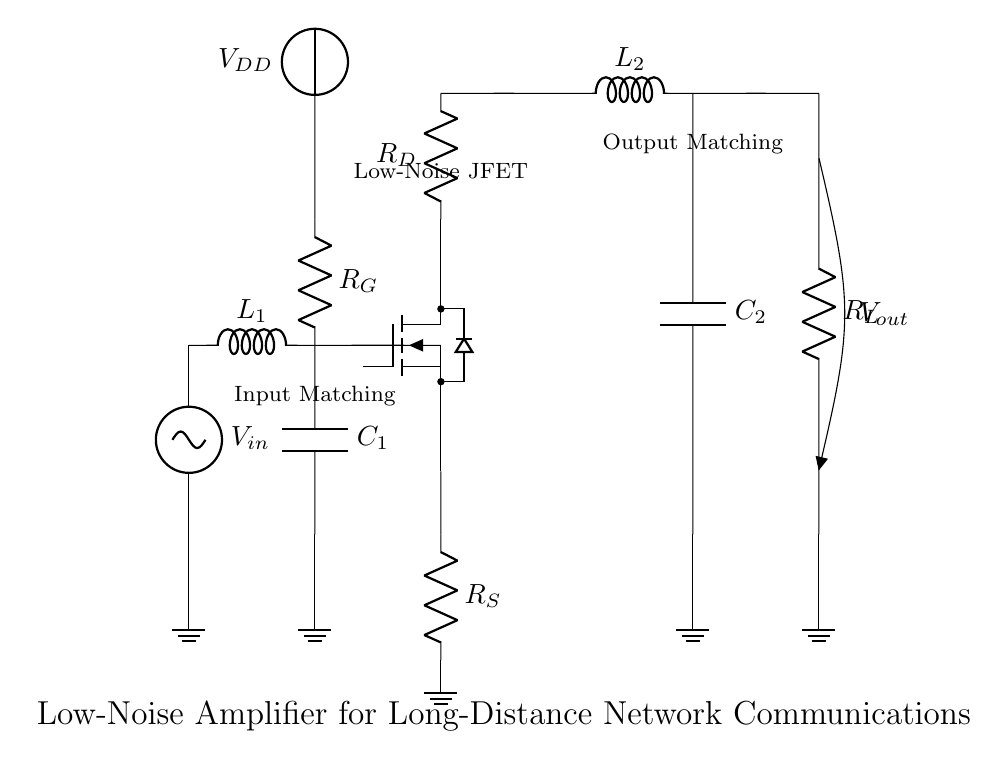What type of amplifier is used in this circuit? The circuit diagram shows a low-noise amplifier, as indicated by the label near the JFET. This type of amplifier is specifically designed to minimize added noise while amplifying weak signals.
Answer: low-noise amplifier What component is represented by "C1"? "C1" is a capacitor, which is used in the input matching network to help filter and match the impedance of the incoming signal. Capacitors in this context improve signal integrity and stability.
Answer: capacitor What is the purpose of the inductor "L1"? "L1" is an inductor that is part of the input matching network, serving to improve the impedance matching between the source and the amplifier. This ensures efficient transfer of the weak signal to the amplifier.
Answer: impedance matching What is the voltage supply in this circuit? The circuit includes a voltage supply labeled "VDD", which provides the necessary power to the low-noise amplifier and its associated components for operation.
Answer: VDD How does the resistor "R_S" function in this circuit? "R_S" works as a source resistor in the low-noise amplifier, setting the biasing conditions for the JFET. It impacts the gain and noise performance of the amplifier, ensuring proper operation in amplification of weak signals.
Answer: source resistor What is the output of the amplifier labeled as? The output of the amplifier is labeled "V_out", indicating where the amplified signal can be accessed from the circuit. This output is crucial for further processing in communications systems.
Answer: V_out What is the significance of the ground connections in the circuit? The ground connections provide a common reference point for all electrical signals in the circuit. This is essential for proper operation as it stabilizes voltage levels and avoids issues with signal integrity due to floating ground potentials.
Answer: common reference 